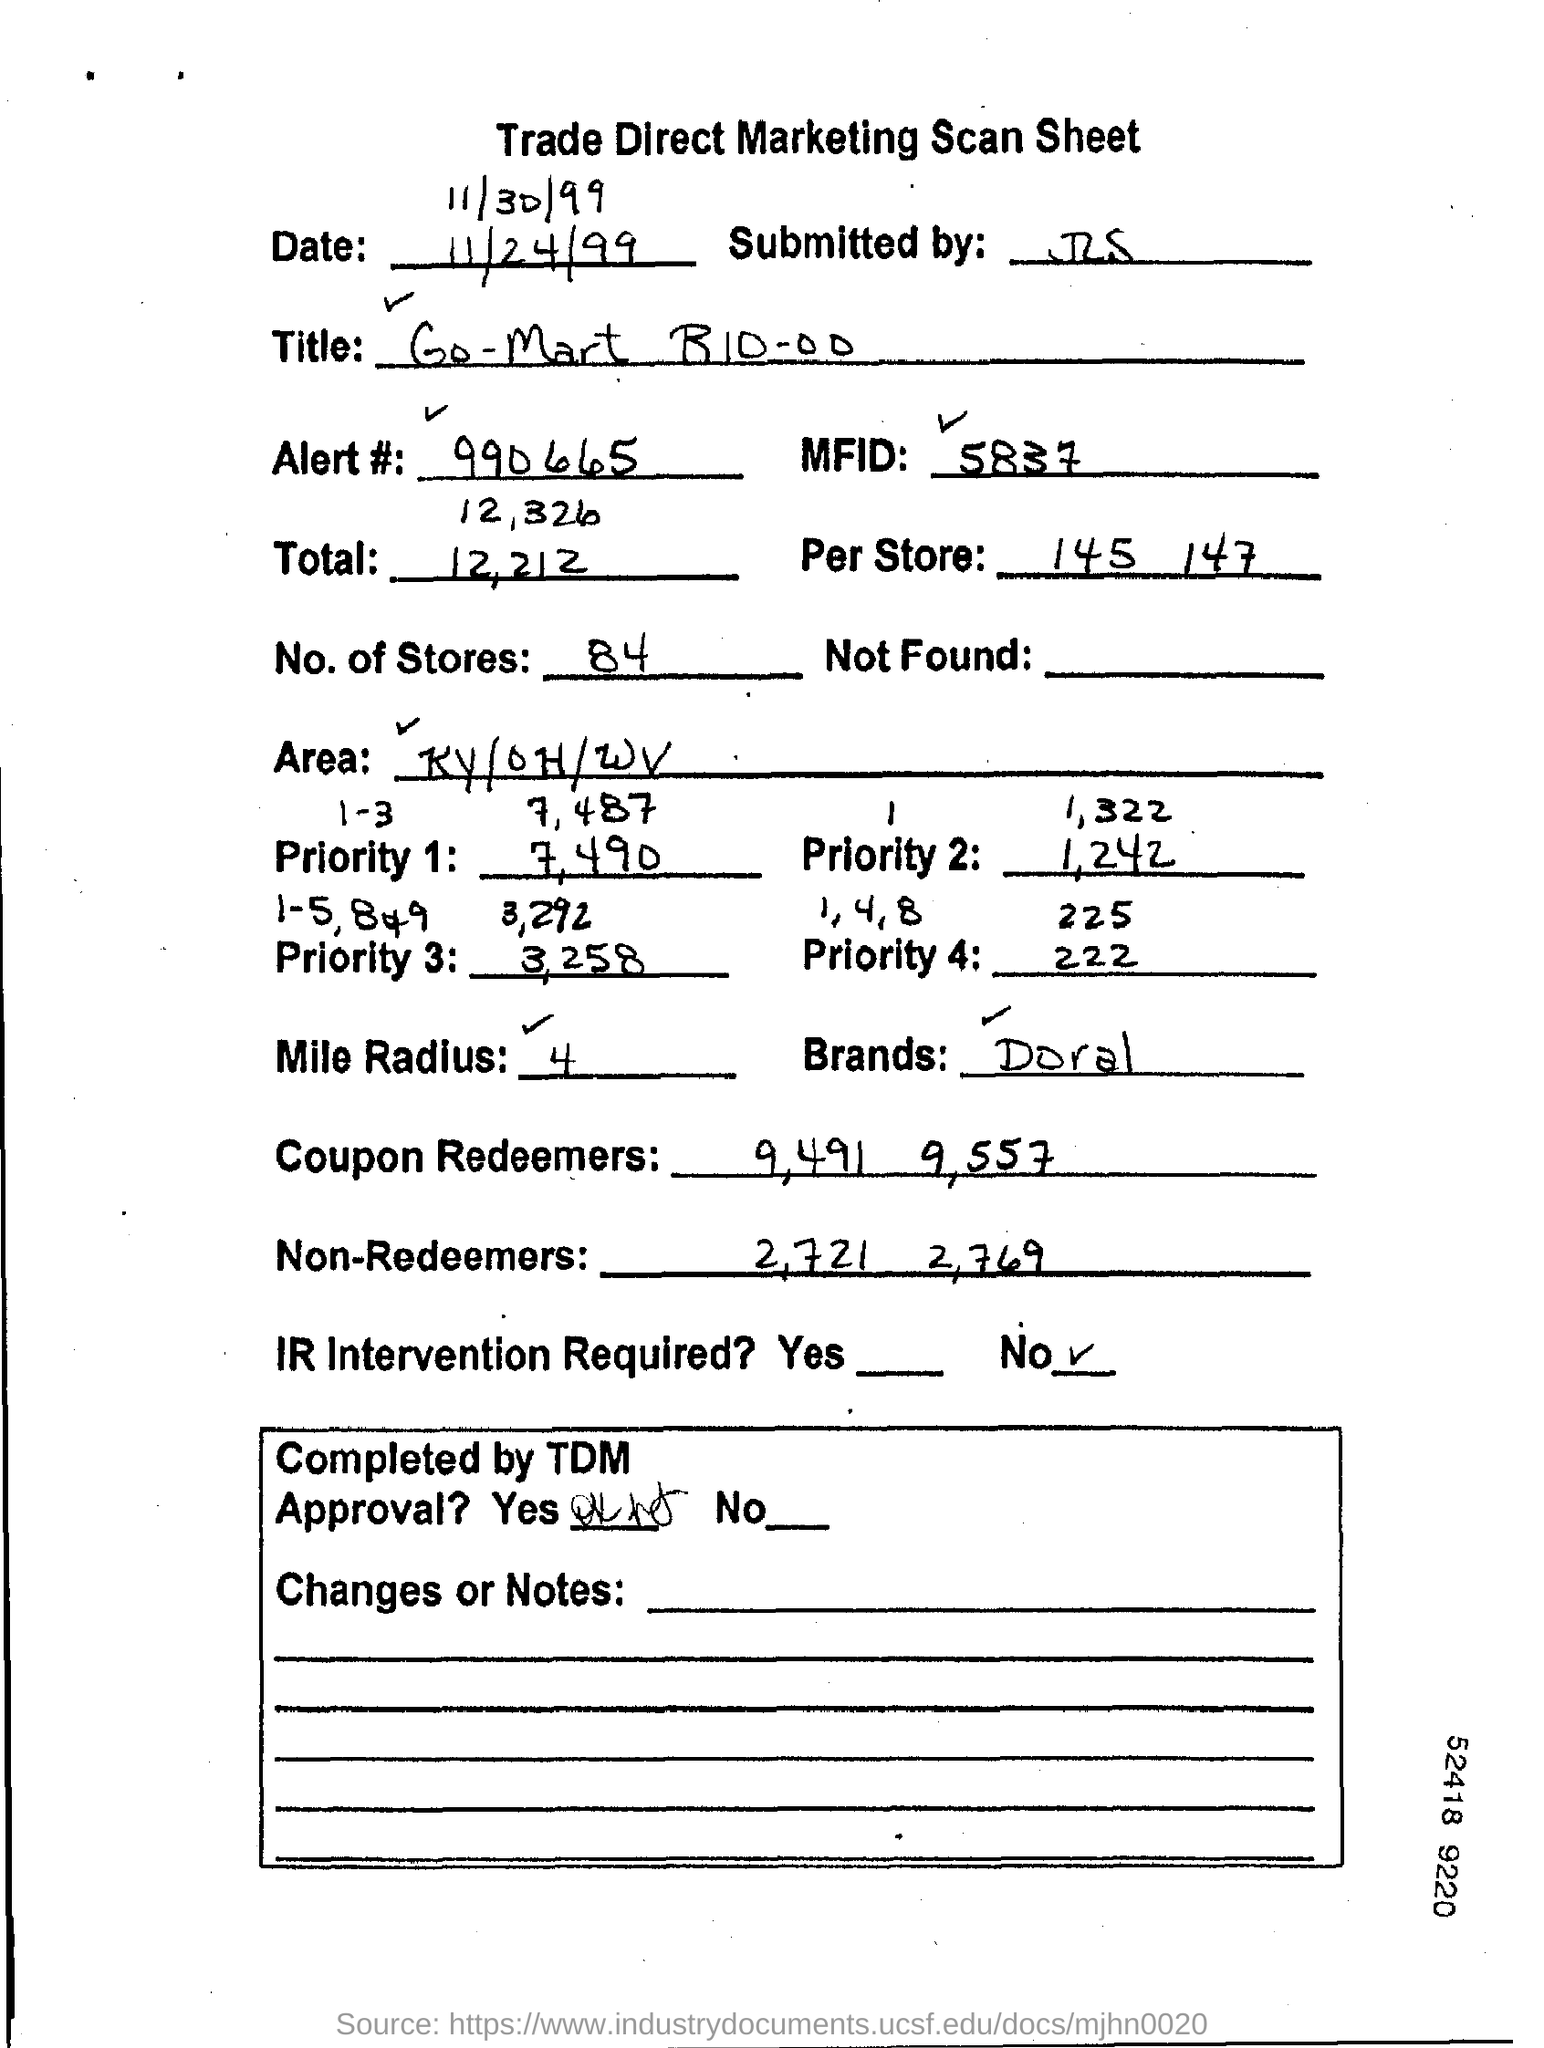Draw attention to some important aspects in this diagram. This marketing detail belongs to the brand Doral. What is the MFID number? It is 5837. It is not necessary to intervene with Infrared technology. According to our records, there are 84 stores. What is the per store number?" refers to the number of incidents per store. 